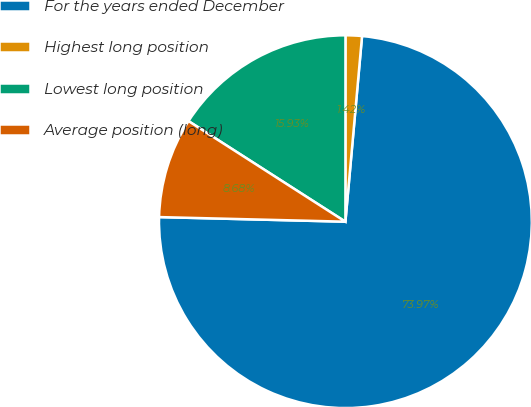<chart> <loc_0><loc_0><loc_500><loc_500><pie_chart><fcel>For the years ended December<fcel>Highest long position<fcel>Lowest long position<fcel>Average position (long)<nl><fcel>73.97%<fcel>1.42%<fcel>15.93%<fcel>8.68%<nl></chart> 